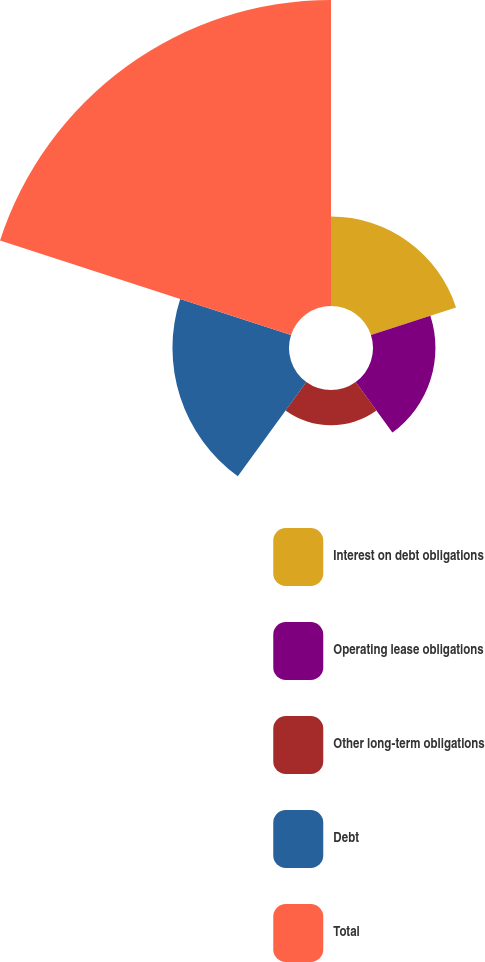<chart> <loc_0><loc_0><loc_500><loc_500><pie_chart><fcel>Interest on debt obligations<fcel>Operating lease obligations<fcel>Other long-term obligations<fcel>Debt<fcel>Total<nl><fcel>14.67%<fcel>10.24%<fcel>5.8%<fcel>19.11%<fcel>50.18%<nl></chart> 